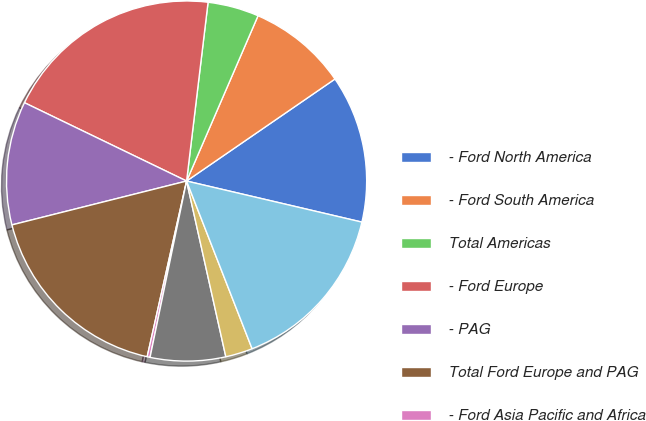Convert chart to OTSL. <chart><loc_0><loc_0><loc_500><loc_500><pie_chart><fcel>- Ford North America<fcel>- Ford South America<fcel>Total Americas<fcel>- Ford Europe<fcel>- PAG<fcel>Total Ford Europe and PAG<fcel>- Ford Asia Pacific and Africa<fcel>- Mazda and Associated<fcel>Total Ford Asia Pacific and<fcel>Other Automotive<nl><fcel>13.25%<fcel>8.92%<fcel>4.59%<fcel>19.74%<fcel>11.08%<fcel>17.57%<fcel>0.26%<fcel>6.75%<fcel>2.43%<fcel>15.41%<nl></chart> 